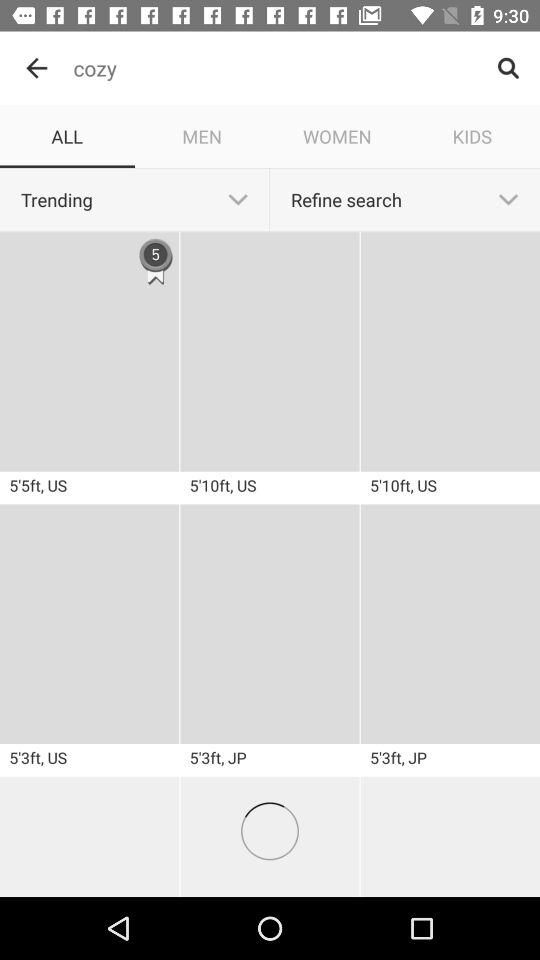Which tab is selected? The selected tab is "ALL". 